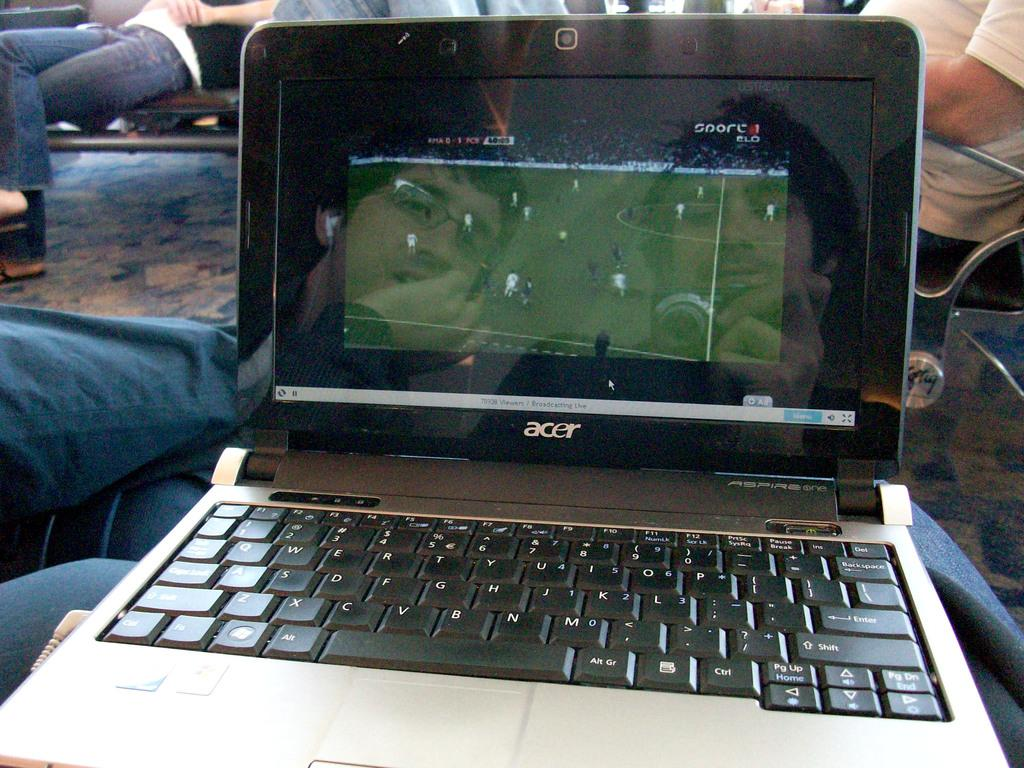<image>
Write a terse but informative summary of the picture. A laptop computer monitor open made by Acer 